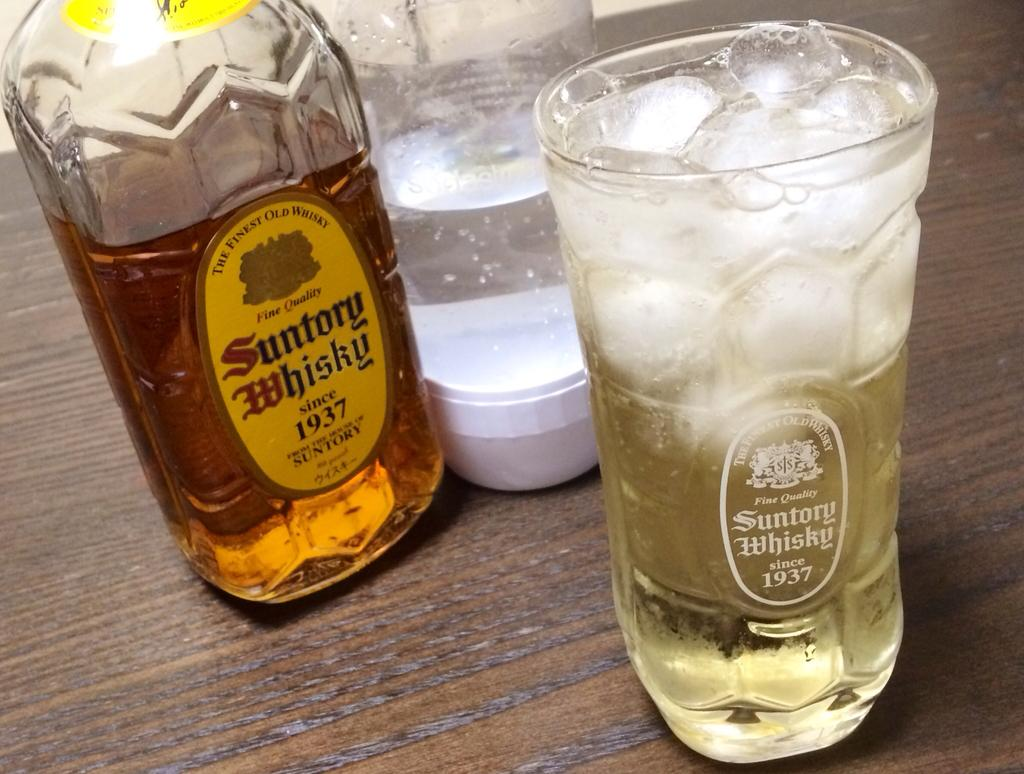What piece of furniture is present in the image? There is a table in the image. What objects are placed on the table? There are glasses and a bottle on the table. What type of head is visible on the table in the image? There is no head visible on the table in the image. 